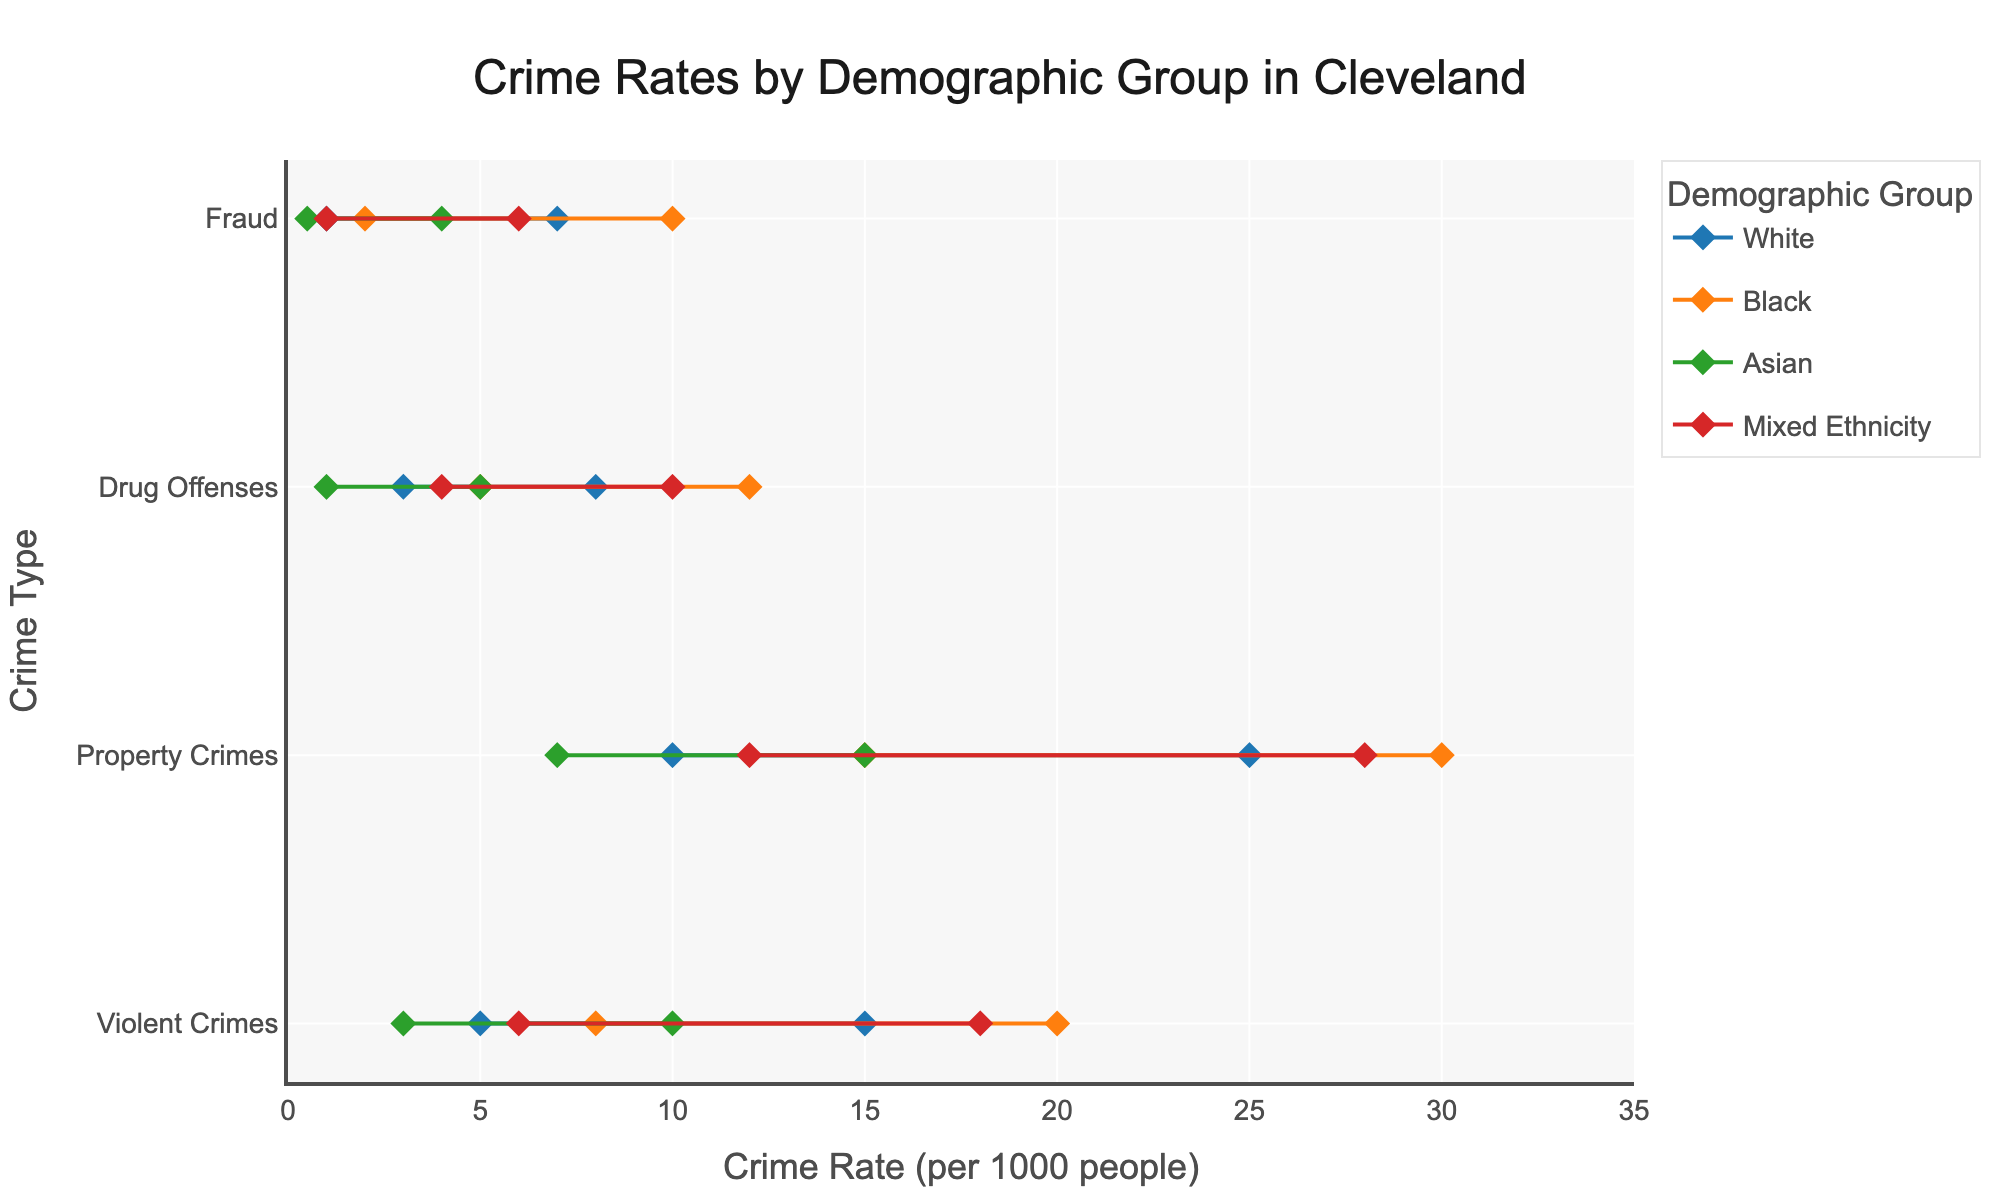What is the title of the figure? The title can be seen at the top of the figure, and it reads "Crime Rates by Demographic Group in Cleveland".
Answer: Crime Rates by Demographic Group in Cleveland Which demographic group has the highest max rate of Property Crimes? By examining the 'Property Crimes' row, the demographic group 'Black' has the highest max rate at 30.0 per 1000 people.
Answer: Black What is the range of Fraud rates for the White demographic group? The range is the difference between the max rate and the min rate. For Fraud, the White demographic group's rates are from 1.0 to 7.0 per 1000 people. The range is 7.0 - 1.0 = 6.0.
Answer: 6.0 Which crime type has the lowest max rate for the Asian demographic group? By comparing the max rates of all crime types for the Asian group, 'Fraud' has the lowest max rate at 4.0 per 1000 people.
Answer: Fraud How do the max rates of Violent Crimes compare between the White and Black demographic groups? For Violent Crimes, the White demographic group has a max rate of 15.0, while the Black demographic group has a max rate of 20.0. Thus, the Black demographic group's max rate is higher.
Answer: The Black group's rate is higher Among all demographic groups, which crime type consistently shows the lowest min rate across the board? By analyzing all the min rates for each crime type across groups, 'Fraud' consistently shows the lowest min rate.
Answer: Fraud What is the average max rate of Property Crimes for all demographic groups? To find the average max rate, sum the max rates of Property Crimes for all groups and divide by the number of groups: (25.0 + 30.0 + 15.0 + 28.0) / 4 = 24.5.
Answer: 24.5 Are there any crime types where the min rate for White and Mixed Ethnicity demographic groups is the same? Comparing the min rates for all crime types, both White and Mixed Ethnicity have a min rate of 1.0 for Fraud.
Answer: Yes, Fraud Which demographic group has the greatest range in rates for Violent Crimes? The range for each group is calculated as max rate - min rate. For Violent Crimes: White (15.0 - 5.0 = 10.0), Black (20.0 - 8.0 = 12.0), Asian (10.0 - 3.0 = 7.0), Mixed Ethnicity (18.0 - 6.0 = 12.0). Both Black and Mixed Ethnicity have the greatest range of 12.0.
Answer: Black and Mixed Ethnicity 